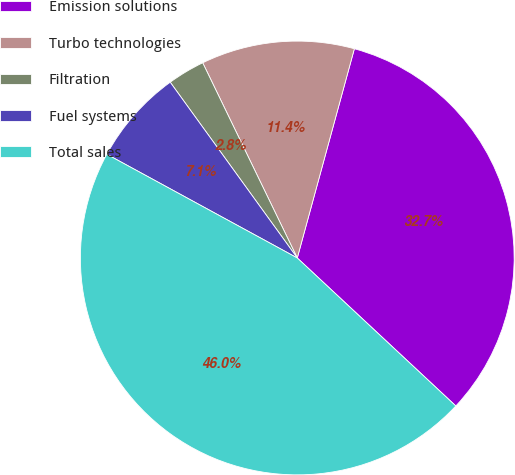Convert chart to OTSL. <chart><loc_0><loc_0><loc_500><loc_500><pie_chart><fcel>Emission solutions<fcel>Turbo technologies<fcel>Filtration<fcel>Fuel systems<fcel>Total sales<nl><fcel>32.71%<fcel>11.42%<fcel>2.78%<fcel>7.1%<fcel>45.98%<nl></chart> 